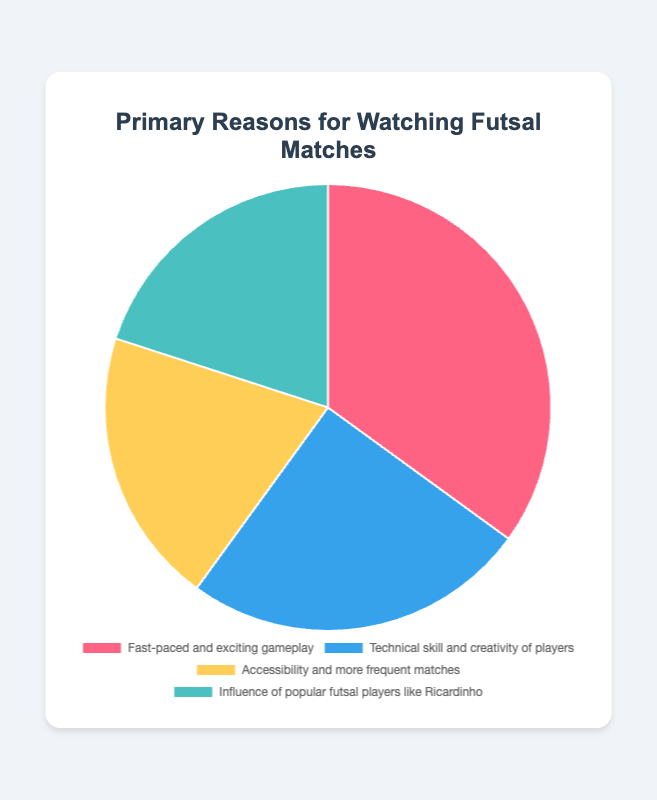What percentage of respondents watch futsal for "Technical skill and creativity of players"? Look at the section labeled "Technical skill and creativity of players" in the pie chart and read the associated percentage.
Answer: 25% Which reason for watching futsal has the highest percentage of respondents? Examine the pie chart and identify the segment with the largest area, which corresponds to the highest percentage. The largest segment is for "Fast-paced and exciting gameplay".
Answer: Fast-paced and exciting gameplay What is the combined percentage of respondents who watch futsal for "Accessibility and more frequent matches" and "Influence of popular futsal players like Ricardinho"? Add the percentages for "Accessibility and more frequent matches" (20%) and "Influence of popular futsal players like Ricardinho" (20%).
Answer: 40% Which reasons have equal percentages of respondents? Compare the percentages in the pie chart to see if any categories have the same values. Both "Accessibility and more frequent matches" and "Influence of popular futsal players like Ricardinho" have 20%.
Answer: Accessibility and more frequent matches, Influence of popular futsal players like Ricardinho What is the difference in percentage between the top two reasons for watching futsal? Identify the top two reasons: "Fast-paced and exciting gameplay" (35%) and "Technical skill and creativity of players" (25%). Subtract 25% from 35%.
Answer: 10% What is the visual color of the segment representing "Fast-paced and exciting gameplay"? Look at the color of the segment labeled "Fast-paced and exciting gameplay" in the pie chart.
Answer: Red Is the percentage of respondents who watch futsal for "Technical skill and creativity of players" more or less than that for "Accessibility and more frequent matches"? Compare the percentages: "Technical skill and creativity of players" (25%) vs "Accessibility and more frequent matches" (20%).
Answer: More What is the sum of the percentages for reasons related to accessibility, frequency, and influence of popular players? Add the percentages for "Accessibility and more frequent matches" (20%) and "Influence of popular futsal players like Ricardinho" (20%).
Answer: 40% How many reasons have a percentage of 20% or higher? Count the segments in the pie chart with percentages that are 20% or higher. The reasons are: "Fast-paced and exciting gameplay" (35%), "Technical skill and creativity of players" (25%), "Accessibility and more frequent matches" (20%), and "Influence of popular futsal players like Ricardinho" (20%).
Answer: 4 What is the average percentage across all the reasons for watching futsal? Add all the percentages and divide by the number of reasons: (35 + 25 + 20 + 20) / 4 = 25.
Answer: 25 